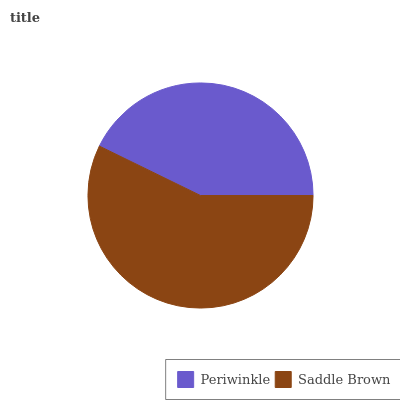Is Periwinkle the minimum?
Answer yes or no. Yes. Is Saddle Brown the maximum?
Answer yes or no. Yes. Is Saddle Brown the minimum?
Answer yes or no. No. Is Saddle Brown greater than Periwinkle?
Answer yes or no. Yes. Is Periwinkle less than Saddle Brown?
Answer yes or no. Yes. Is Periwinkle greater than Saddle Brown?
Answer yes or no. No. Is Saddle Brown less than Periwinkle?
Answer yes or no. No. Is Saddle Brown the high median?
Answer yes or no. Yes. Is Periwinkle the low median?
Answer yes or no. Yes. Is Periwinkle the high median?
Answer yes or no. No. Is Saddle Brown the low median?
Answer yes or no. No. 